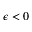<formula> <loc_0><loc_0><loc_500><loc_500>\epsilon < 0</formula> 